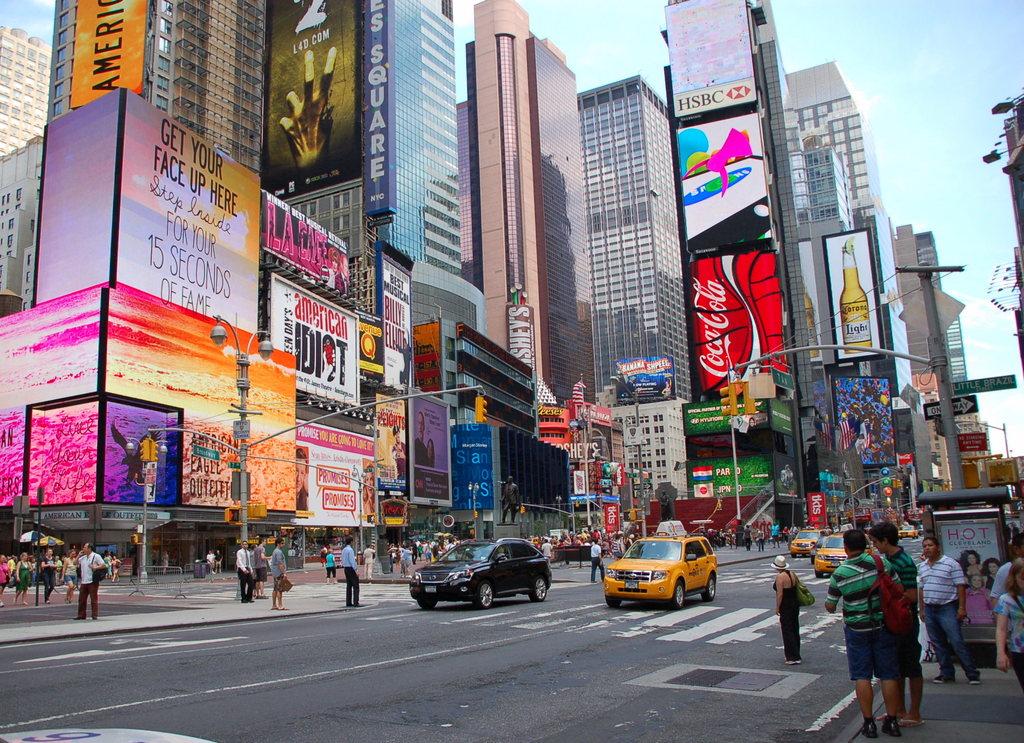What beer company has an advertisement here?
Make the answer very short. Corona. 